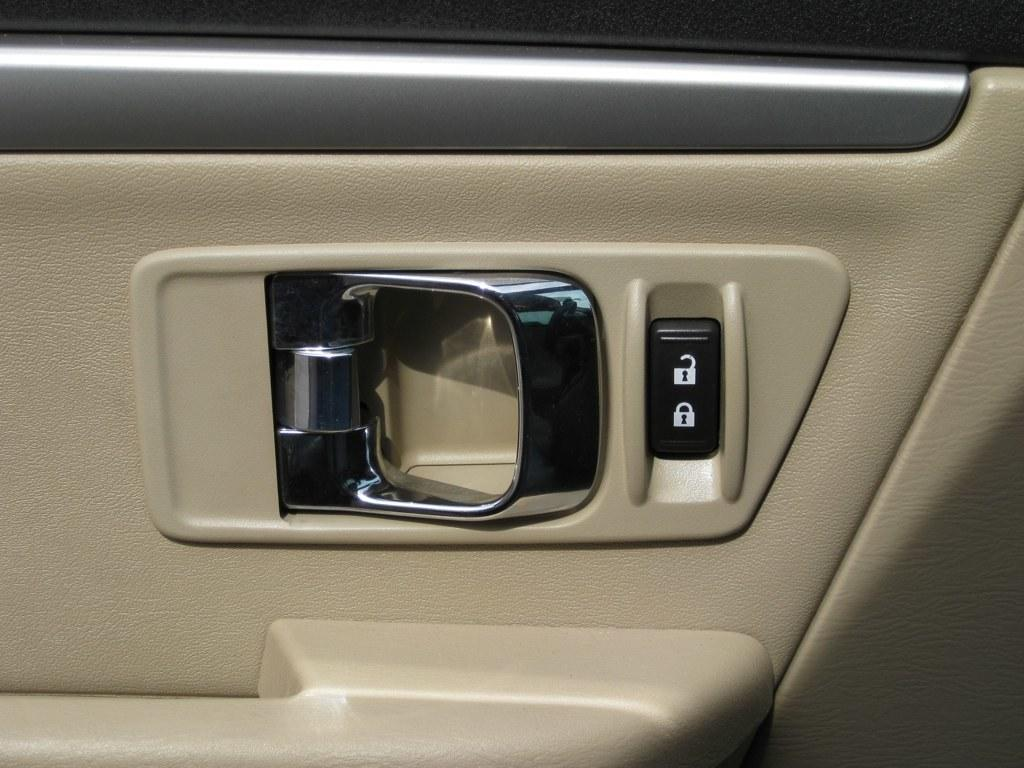What type of object has a door in the image? The door is part of a vehicle in the image. Can you describe the door in the image? The door has a door handle in the image. What type of lace can be seen on the tray in the image? There is no tray or lace present in the image; it features a door that is part of a vehicle. What type of box is located next to the door in the image? There is no box present in the image; it only features a door with a door handle. 